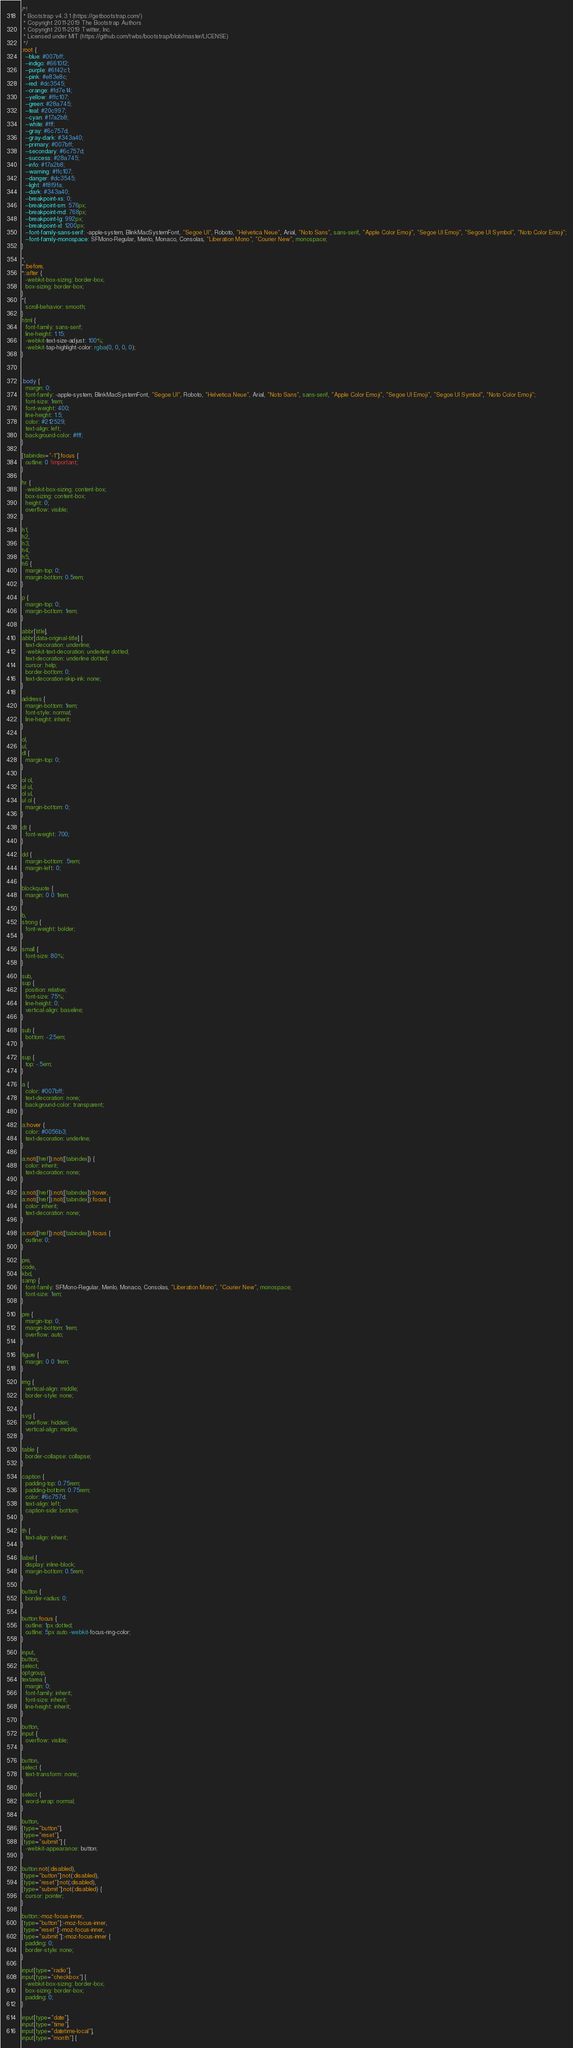Convert code to text. <code><loc_0><loc_0><loc_500><loc_500><_CSS_>/*!
 * Bootstrap v4.3.1 (https://getbootstrap.com/)
 * Copyright 2011-2019 The Bootstrap Authors
 * Copyright 2011-2019 Twitter, Inc.
 * Licensed under MIT (https://github.com/twbs/bootstrap/blob/master/LICENSE)
 */
:root {
  --blue: #007bff;
  --indigo: #6610f2;
  --purple: #6f42c1;
  --pink: #e83e8c;
  --red: #dc3545;
  --orange: #fd7e14;
  --yellow: #ffc107;
  --green: #28a745;
  --teal: #20c997;
  --cyan: #17a2b8;
  --white: #fff;
  --gray: #6c757d;
  --gray-dark: #343a40;
  --primary: #007bff;
  --secondary: #6c757d;
  --success: #28a745;
  --info: #17a2b8;
  --warning: #ffc107;
  --danger: #dc3545;
  --light: #f8f9fa;
  --dark: #343a40;
  --breakpoint-xs: 0;
  --breakpoint-sm: 576px;
  --breakpoint-md: 768px;
  --breakpoint-lg: 992px;
  --breakpoint-xl: 1200px;
  --font-family-sans-serif: -apple-system, BlinkMacSystemFont, "Segoe UI", Roboto, "Helvetica Neue", Arial, "Noto Sans", sans-serif, "Apple Color Emoji", "Segoe UI Emoji", "Segoe UI Symbol", "Noto Color Emoji";
  --font-family-monospace: SFMono-Regular, Menlo, Monaco, Consolas, "Liberation Mono", "Courier New", monospace;
}

*,
*::before,
*::after {
  -webkit-box-sizing: border-box;
  box-sizing: border-box;
}
*{
  scroll-behavior: smooth;
}
html {
  font-family: sans-serif;
  line-height: 1.15;
  -webkit-text-size-adjust: 100%;
  -webkit-tap-highlight-color: rgba(0, 0, 0, 0);
}



.body {
  margin: 0;
  font-family: -apple-system, BlinkMacSystemFont, "Segoe UI", Roboto, "Helvetica Neue", Arial, "Noto Sans", sans-serif, "Apple Color Emoji", "Segoe UI Emoji", "Segoe UI Symbol", "Noto Color Emoji";
  font-size: 1rem;
  font-weight: 400;
  line-height: 1.5;
  color: #212529;
  text-align: left;
  background-color: #fff;
}

[tabindex="-1"]:focus {
  outline: 0 !important;
}

hr {
  -webkit-box-sizing: content-box;
  box-sizing: content-box;
  height: 0;
  overflow: visible;
}

h1,
h2,
h3,
h4,
h5,
h6 {
  margin-top: 0;
  margin-bottom: 0.5rem;
}

p {
  margin-top: 0;
  margin-bottom: 1rem;
}

abbr[title],
abbr[data-original-title] {
  text-decoration: underline;
  -webkit-text-decoration: underline dotted;
  text-decoration: underline dotted;
  cursor: help;
  border-bottom: 0;
  text-decoration-skip-ink: none;
}

address {
  margin-bottom: 1rem;
  font-style: normal;
  line-height: inherit;
}

ol,
ul,
dl {
  margin-top: 0;
}

ol ol,
ul ul,
ol ul,
ul ol {
  margin-bottom: 0;
}

dt {
  font-weight: 700;
}

dd {
  margin-bottom: .5rem;
  margin-left: 0;
}

blockquote {
  margin: 0 0 1rem;
}

b,
strong {
  font-weight: bolder;
}

small {
  font-size: 80%;
}

sub,
sup {
  position: relative;
  font-size: 75%;
  line-height: 0;
  vertical-align: baseline;
}

sub {
  bottom: -.25em;
}

sup {
  top: -.5em;
}

a {
  color: #007bff;
  text-decoration: none;
  background-color: transparent;
}

a:hover {
  color: #0056b3;
  text-decoration: underline;
}

a:not([href]):not([tabindex]) {
  color: inherit;
  text-decoration: none;
}

a:not([href]):not([tabindex]):hover,
a:not([href]):not([tabindex]):focus {
  color: inherit;
  text-decoration: none;
}

a:not([href]):not([tabindex]):focus {
  outline: 0;
}

pre,
code,
kbd,
samp {
  font-family: SFMono-Regular, Menlo, Monaco, Consolas, "Liberation Mono", "Courier New", monospace;
  font-size: 1em;
}

pre {
  margin-top: 0;
  margin-bottom: 1rem;
  overflow: auto;
}

figure {
  margin: 0 0 1rem;
}

img {
  vertical-align: middle;
  border-style: none;
}

svg {
  overflow: hidden;
  vertical-align: middle;
}

table {
  border-collapse: collapse;
}

caption {
  padding-top: 0.75rem;
  padding-bottom: 0.75rem;
  color: #6c757d;
  text-align: left;
  caption-side: bottom;
}

th {
  text-align: inherit;
}

label {
  display: inline-block;
  margin-bottom: 0.5rem;
}

button {
  border-radius: 0;
}

button:focus {
  outline: 1px dotted;
  outline: 5px auto -webkit-focus-ring-color;
}

input,
button,
select,
optgroup,
textarea {
  margin: 0;
  font-family: inherit;
  font-size: inherit;
  line-height: inherit;
}

button,
input {
  overflow: visible;
}

button,
select {
  text-transform: none;
}

select {
  word-wrap: normal;
}

button,
[type="button"],
[type="reset"],
[type="submit"] {
  -webkit-appearance: button;
}

button:not(:disabled),
[type="button"]:not(:disabled),
[type="reset"]:not(:disabled),
[type="submit"]:not(:disabled) {
  cursor: pointer;
}

button::-moz-focus-inner,
[type="button"]::-moz-focus-inner,
[type="reset"]::-moz-focus-inner,
[type="submit"]::-moz-focus-inner {
  padding: 0;
  border-style: none;
}

input[type="radio"],
input[type="checkbox"] {
  -webkit-box-sizing: border-box;
  box-sizing: border-box;
  padding: 0;
}

input[type="date"],
input[type="time"],
input[type="datetime-local"],
input[type="month"] {</code> 